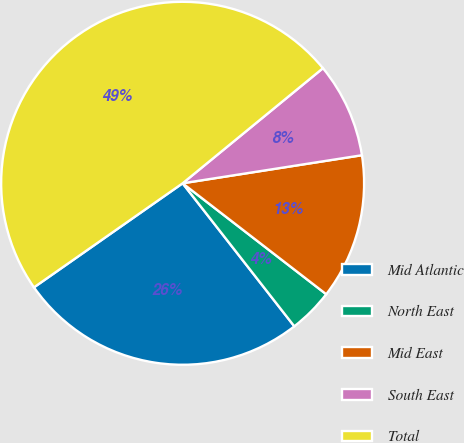Convert chart. <chart><loc_0><loc_0><loc_500><loc_500><pie_chart><fcel>Mid Atlantic<fcel>North East<fcel>Mid East<fcel>South East<fcel>Total<nl><fcel>25.83%<fcel>3.98%<fcel>12.94%<fcel>8.46%<fcel>48.79%<nl></chart> 